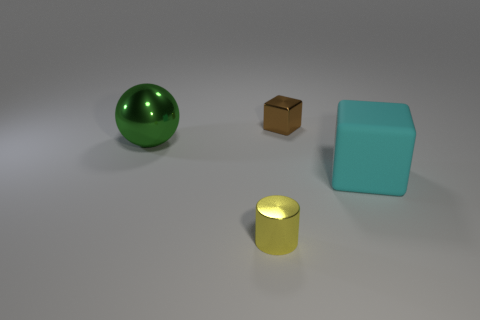Are there any yellow things made of the same material as the tiny cube?
Make the answer very short. Yes. Are there fewer big green spheres than big red objects?
Provide a succinct answer. No. There is a tiny object that is in front of the rubber thing; is it the same color as the big shiny thing?
Give a very brief answer. No. What is the big thing that is on the left side of the tiny thing that is behind the metal thing in front of the large green ball made of?
Make the answer very short. Metal. Are there any tiny metal cubes that have the same color as the large metal sphere?
Offer a very short reply. No. Are there fewer big green metal things left of the large cyan matte block than tiny blocks?
Your response must be concise. No. There is a shiny object that is in front of the sphere; is its size the same as the big metal object?
Offer a terse response. No. What number of tiny things are both behind the cyan object and to the left of the small brown thing?
Provide a short and direct response. 0. There is a object that is to the left of the small metallic thing in front of the brown object; what size is it?
Offer a terse response. Large. Are there fewer blocks left of the big rubber cube than small metal cylinders that are behind the tiny shiny cylinder?
Offer a terse response. No. 